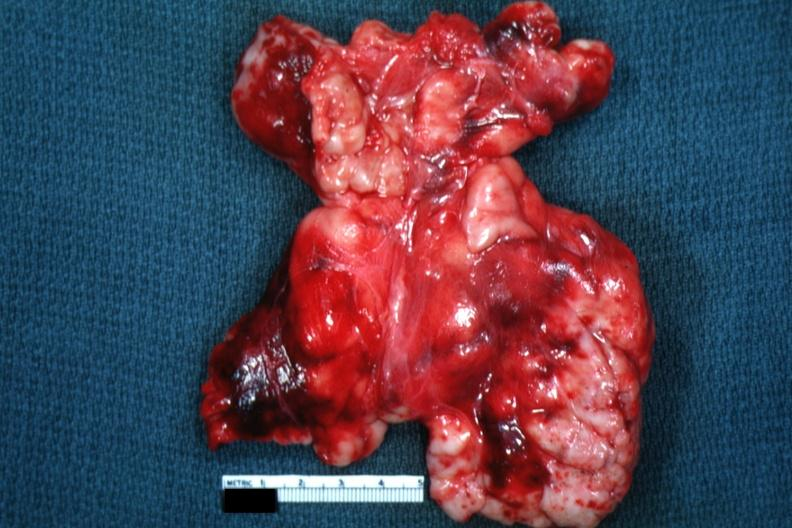s hematologic present?
Answer the question using a single word or phrase. Yes 